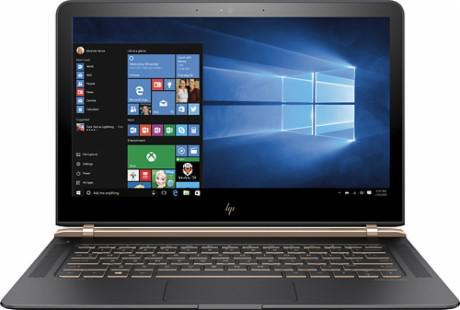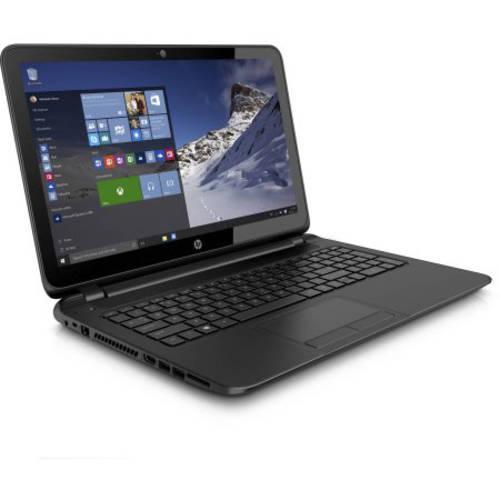The first image is the image on the left, the second image is the image on the right. Evaluate the accuracy of this statement regarding the images: "One image shows a suite of devices on a plain background.". Is it true? Answer yes or no. No. 